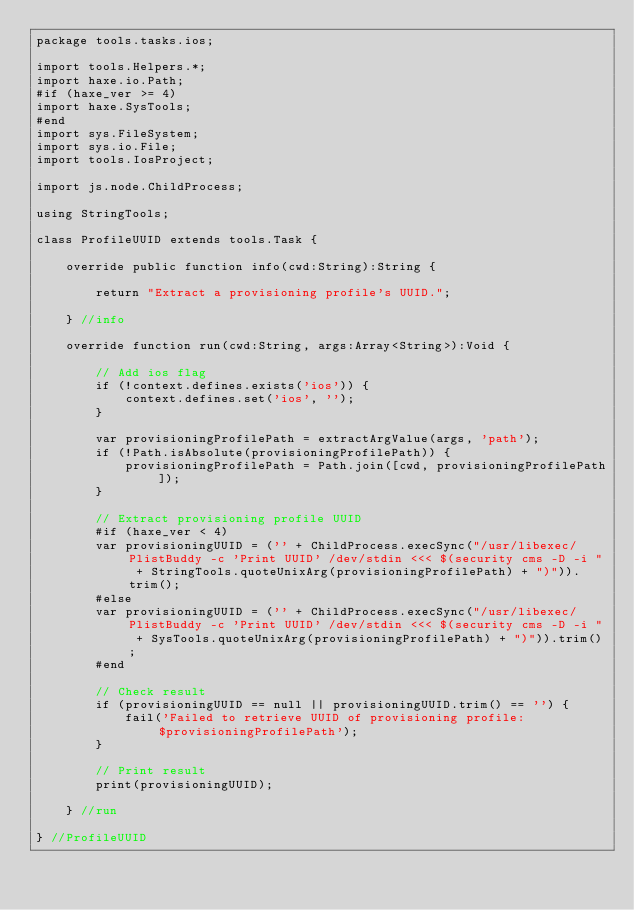<code> <loc_0><loc_0><loc_500><loc_500><_Haxe_>package tools.tasks.ios;

import tools.Helpers.*;
import haxe.io.Path;
#if (haxe_ver >= 4)
import haxe.SysTools;
#end
import sys.FileSystem;
import sys.io.File;
import tools.IosProject;

import js.node.ChildProcess;

using StringTools;

class ProfileUUID extends tools.Task {

    override public function info(cwd:String):String {

        return "Extract a provisioning profile's UUID.";

    } //info

    override function run(cwd:String, args:Array<String>):Void {

        // Add ios flag
        if (!context.defines.exists('ios')) {
            context.defines.set('ios', '');
        }

        var provisioningProfilePath = extractArgValue(args, 'path');
        if (!Path.isAbsolute(provisioningProfilePath)) {
            provisioningProfilePath = Path.join([cwd, provisioningProfilePath]);
        }

        // Extract provisioning profile UUID
        #if (haxe_ver < 4)
        var provisioningUUID = ('' + ChildProcess.execSync("/usr/libexec/PlistBuddy -c 'Print UUID' /dev/stdin <<< $(security cms -D -i " + StringTools.quoteUnixArg(provisioningProfilePath) + ")")).trim();
        #else
        var provisioningUUID = ('' + ChildProcess.execSync("/usr/libexec/PlistBuddy -c 'Print UUID' /dev/stdin <<< $(security cms -D -i " + SysTools.quoteUnixArg(provisioningProfilePath) + ")")).trim();
        #end

        // Check result
        if (provisioningUUID == null || provisioningUUID.trim() == '') {
            fail('Failed to retrieve UUID of provisioning profile: $provisioningProfilePath');
        }

        // Print result
        print(provisioningUUID);

    } //run

} //ProfileUUID
</code> 